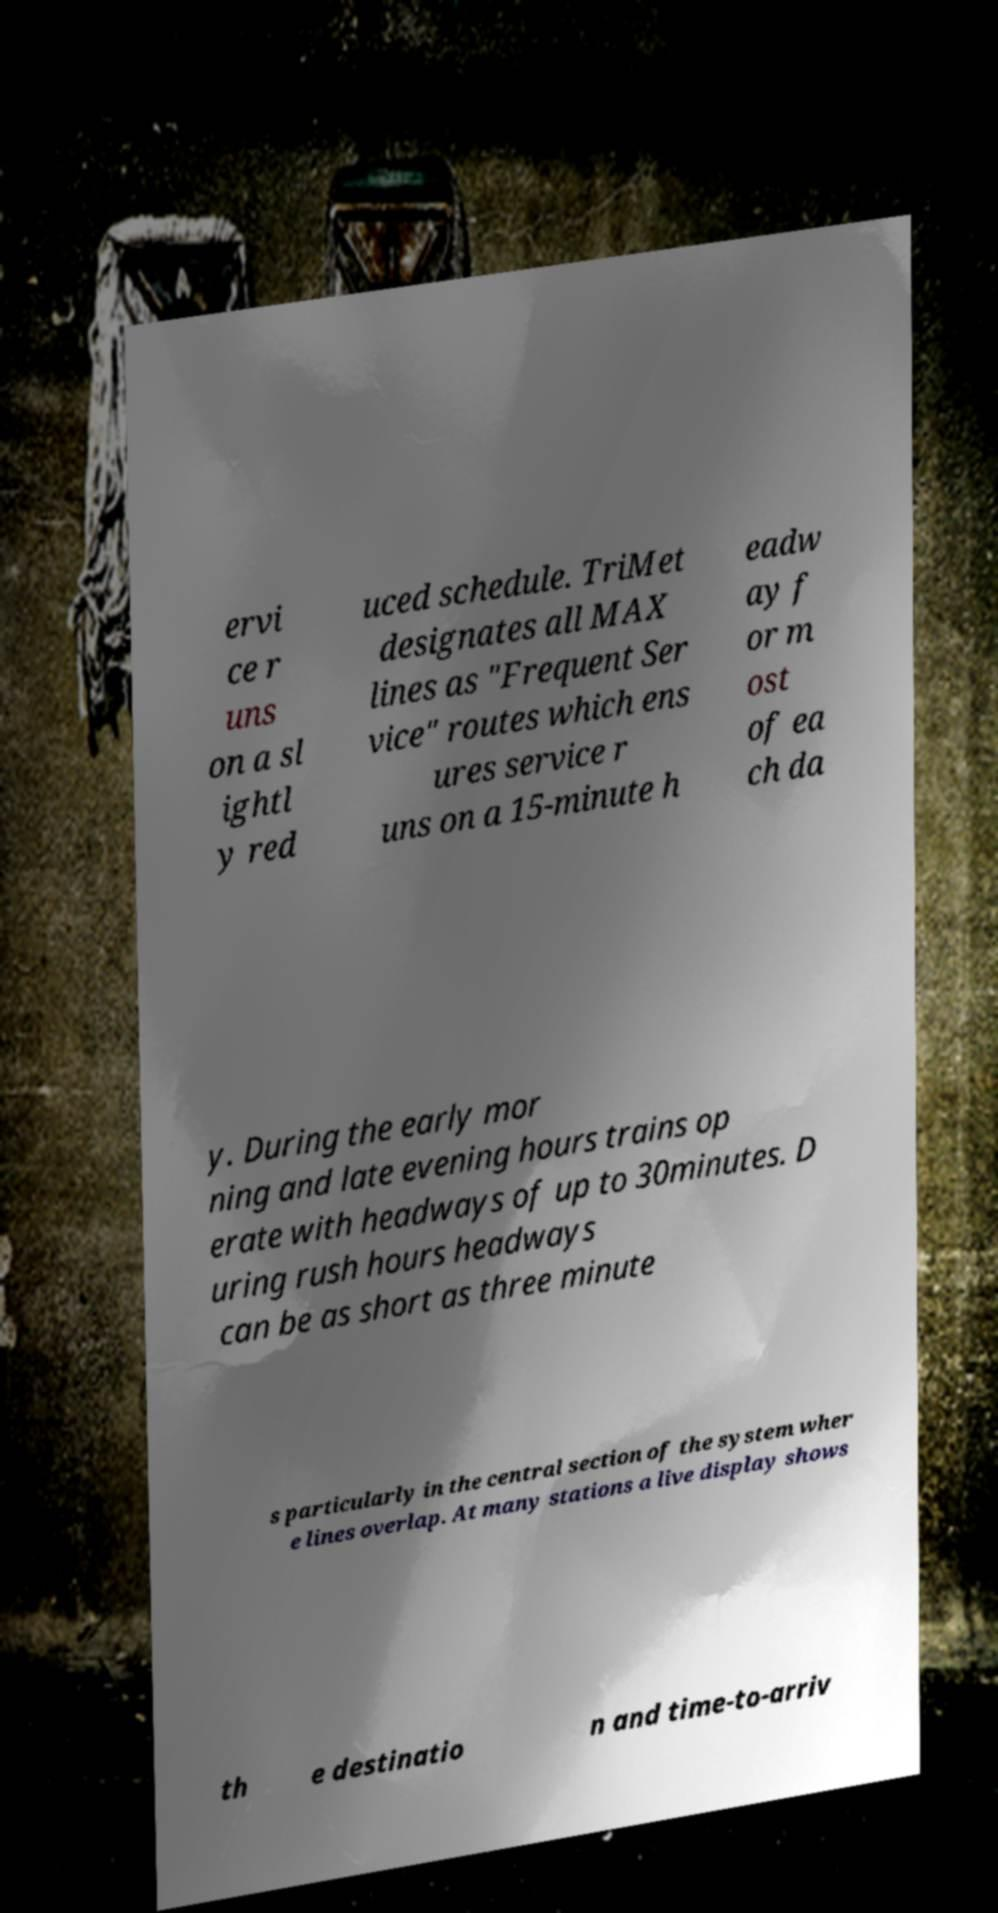For documentation purposes, I need the text within this image transcribed. Could you provide that? ervi ce r uns on a sl ightl y red uced schedule. TriMet designates all MAX lines as "Frequent Ser vice" routes which ens ures service r uns on a 15-minute h eadw ay f or m ost of ea ch da y. During the early mor ning and late evening hours trains op erate with headways of up to 30minutes. D uring rush hours headways can be as short as three minute s particularly in the central section of the system wher e lines overlap. At many stations a live display shows th e destinatio n and time-to-arriv 